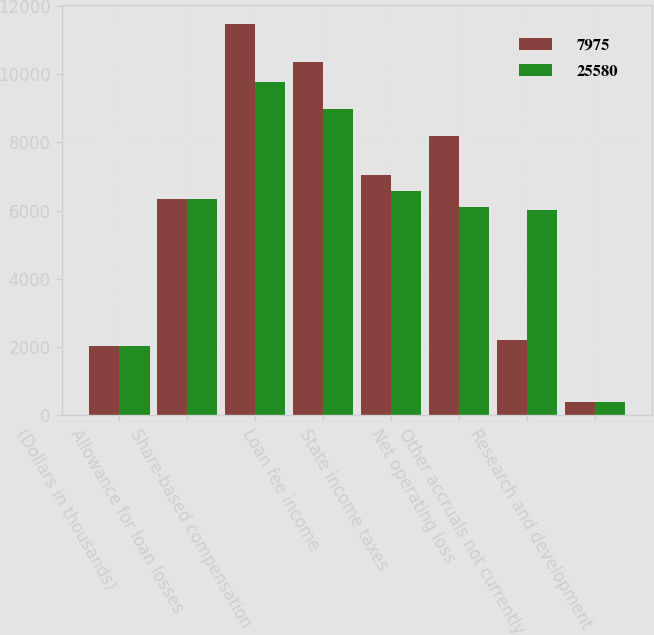<chart> <loc_0><loc_0><loc_500><loc_500><stacked_bar_chart><ecel><fcel>(Dollars in thousands)<fcel>Allowance for loan losses<fcel>Share-based compensation<fcel>Loan fee income<fcel>State income taxes<fcel>Net operating loss<fcel>Other accruals not currently<fcel>Research and development<nl><fcel>7975<fcel>2012<fcel>6332.5<fcel>11478<fcel>10356<fcel>7042<fcel>8175<fcel>2205<fcel>364<nl><fcel>25580<fcel>2011<fcel>6332.5<fcel>9786<fcel>8969<fcel>6576<fcel>6089<fcel>6010<fcel>364<nl></chart> 